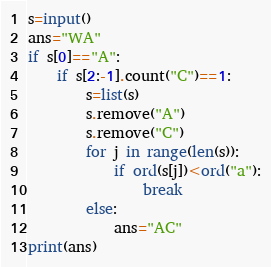Convert code to text. <code><loc_0><loc_0><loc_500><loc_500><_Python_>s=input()
ans="WA"
if s[0]=="A":
    if s[2:-1].count("C")==1:
        s=list(s)
        s.remove("A")
        s.remove("C")
        for j in range(len(s)):
            if ord(s[j])<ord("a"):
                break
        else:
            ans="AC"
print(ans)</code> 